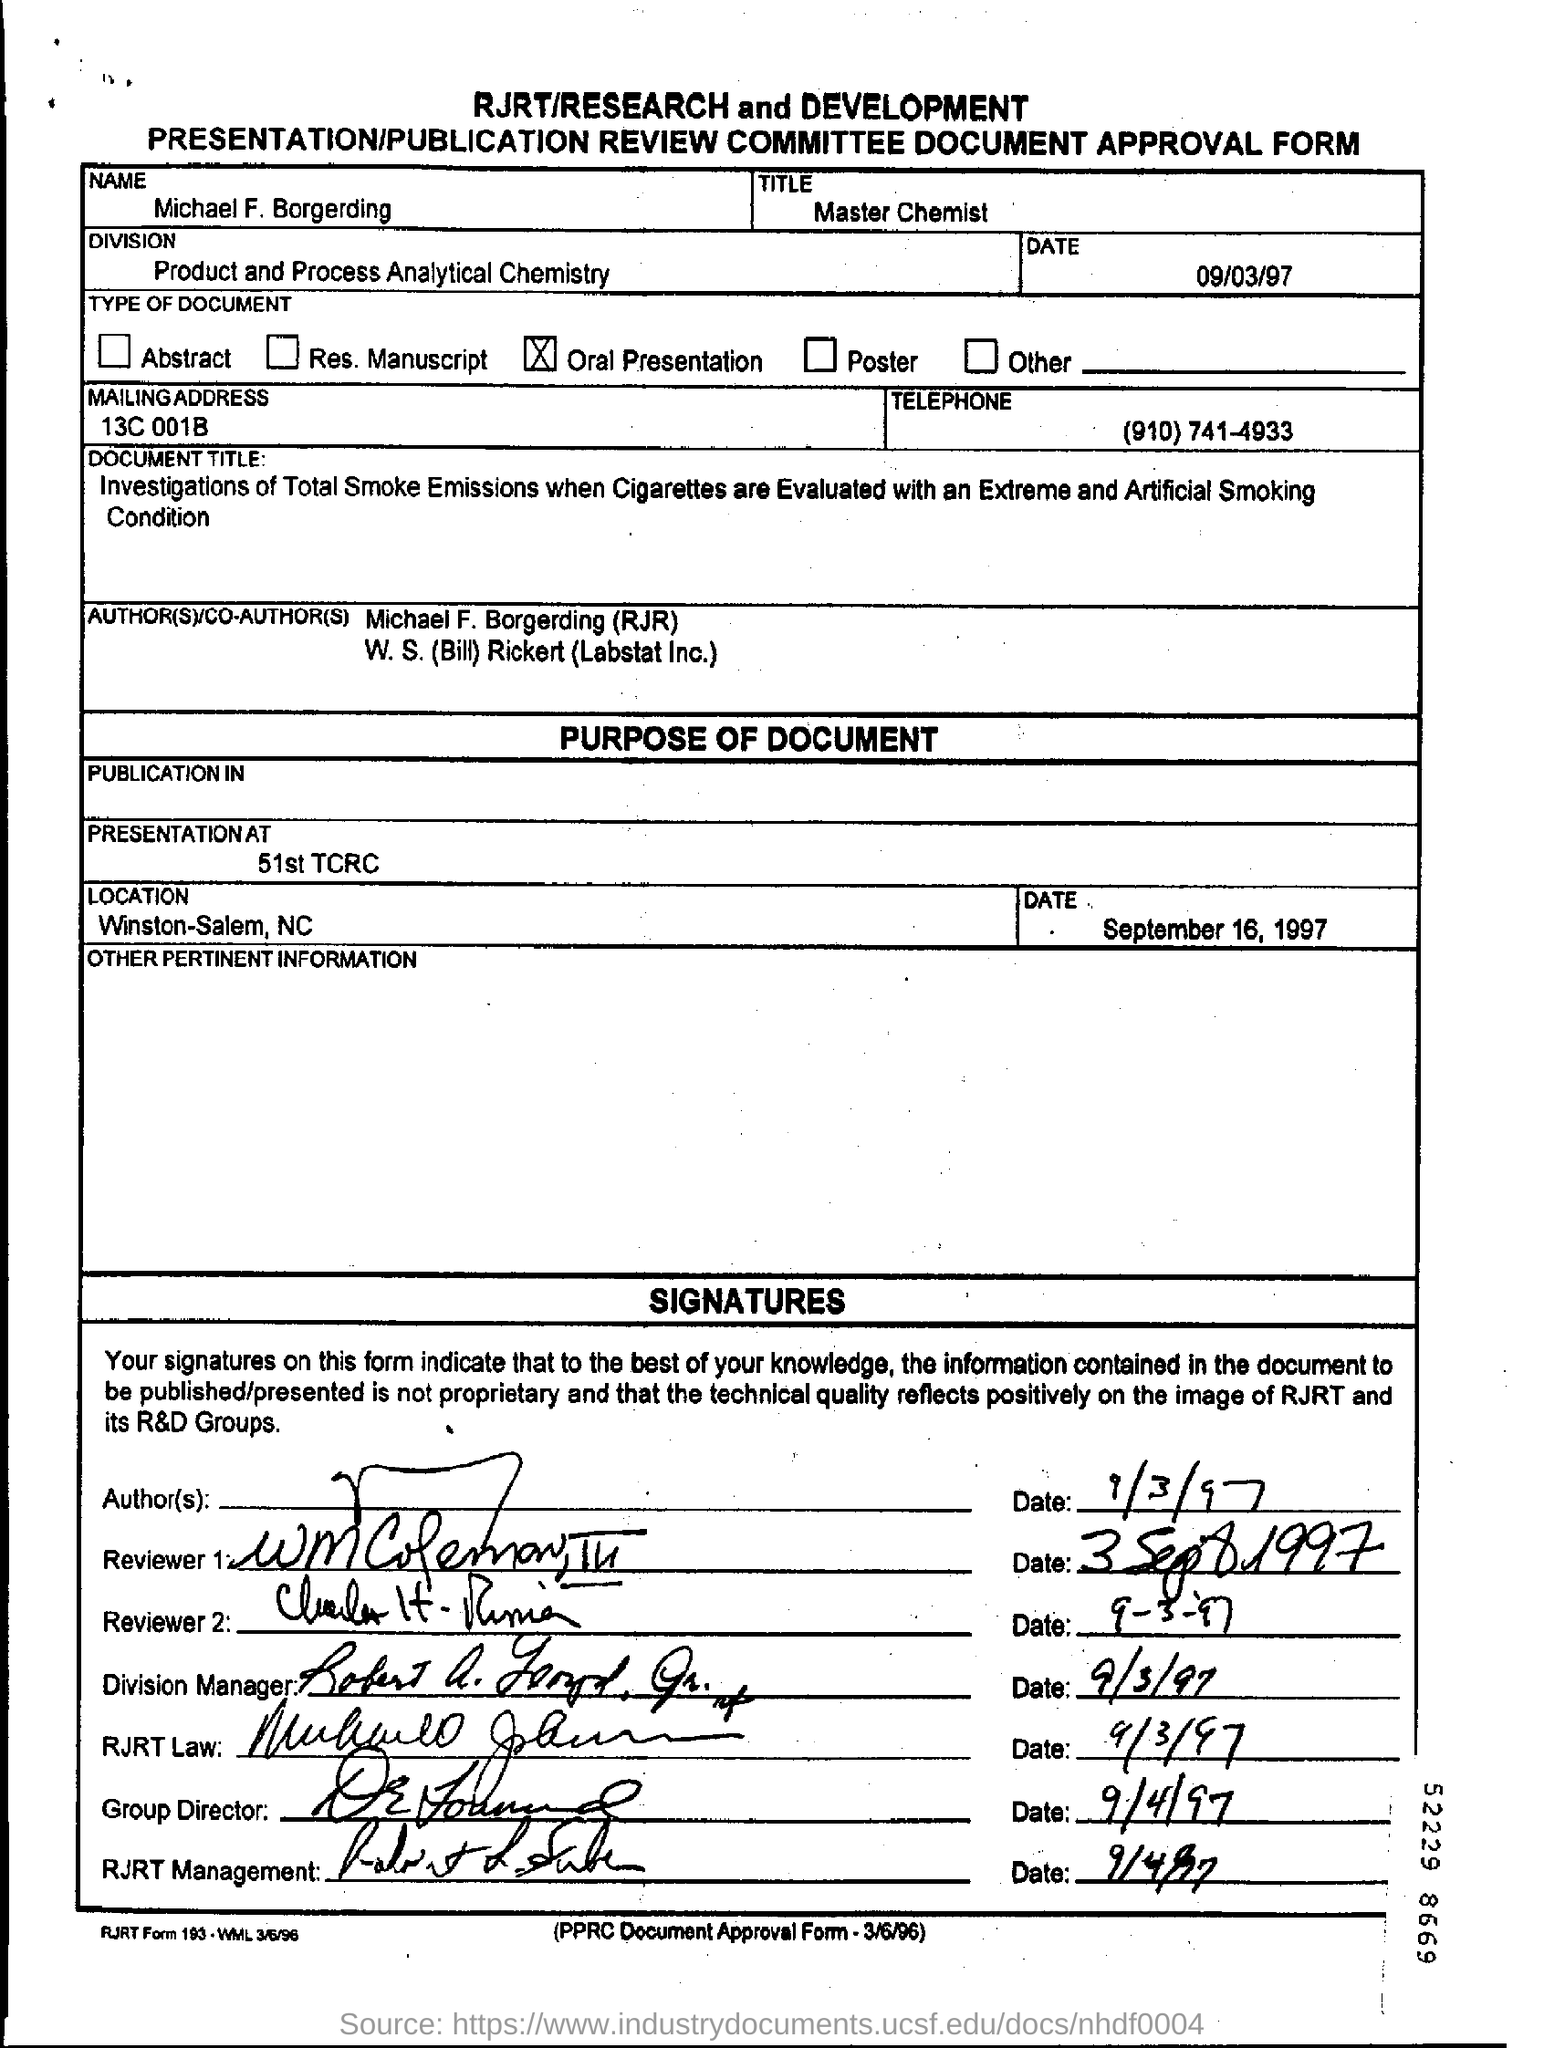What is the designation of Michael F. Borgerding
Your answer should be very brief. Master chemist. Where is the presentation held?
Your answer should be compact. 51st TCRC. Which type of presentation is conducted?
Provide a short and direct response. Oral Presentation. As per the form, what type of document is it?
Keep it short and to the point. Oral Presentation. What is the "mailing address" as per the form?
Offer a terse response. 13C 001B. When did Group Director sign this?
Your answer should be very brief. 9/4/97. When did division manager sign this?
Ensure brevity in your answer.  9/3/97. When did reviewer 2 sign ?
Make the answer very short. 9-3-'97. 